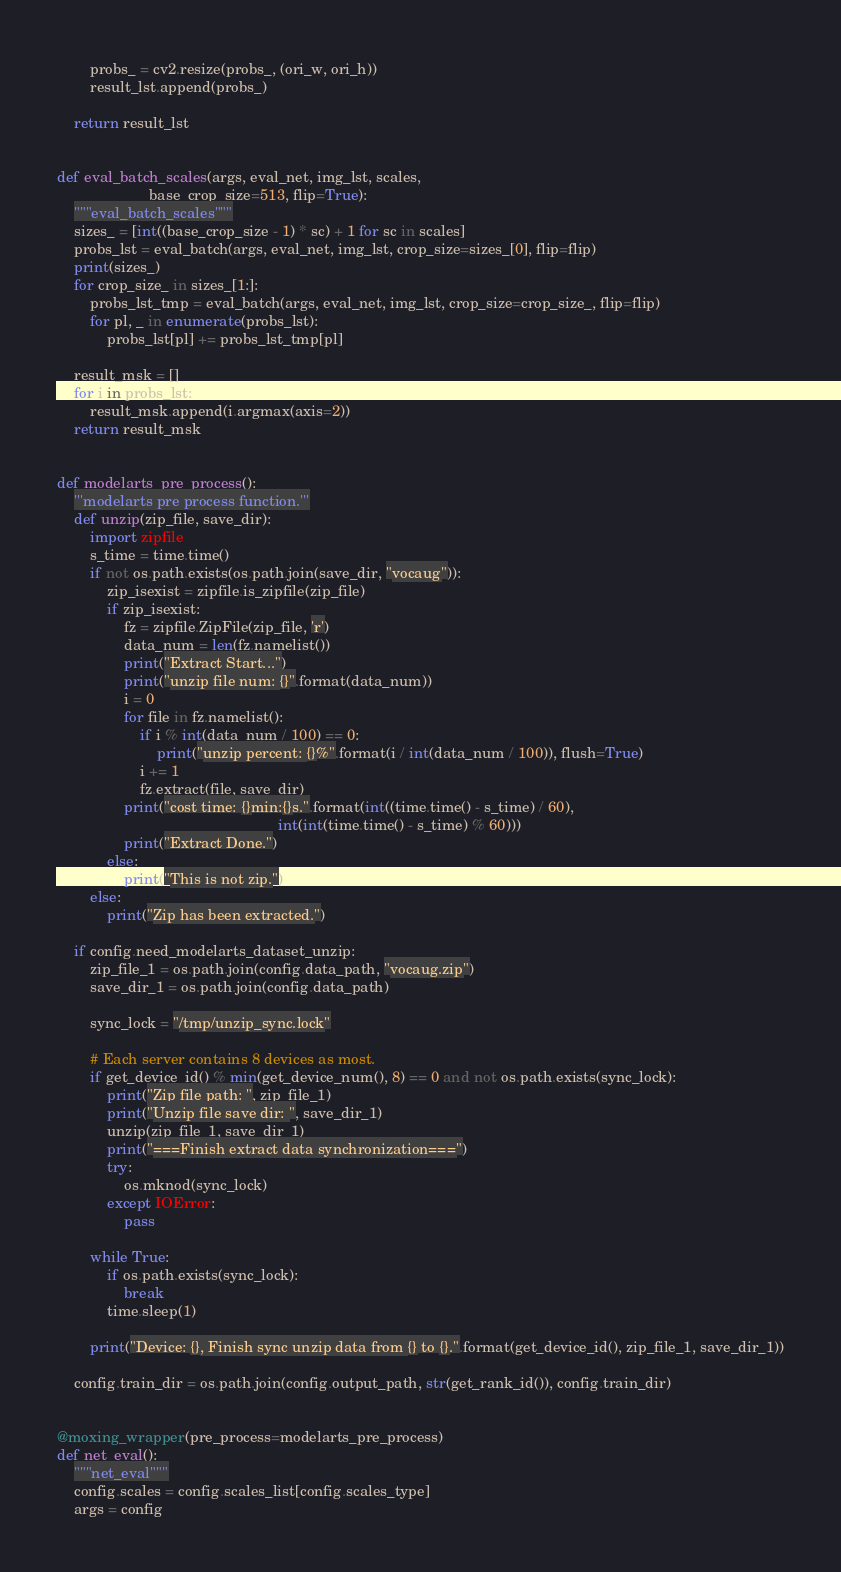Convert code to text. <code><loc_0><loc_0><loc_500><loc_500><_Python_>        probs_ = cv2.resize(probs_, (ori_w, ori_h))
        result_lst.append(probs_)

    return result_lst


def eval_batch_scales(args, eval_net, img_lst, scales,
                      base_crop_size=513, flip=True):
    """eval_batch_scales"""
    sizes_ = [int((base_crop_size - 1) * sc) + 1 for sc in scales]
    probs_lst = eval_batch(args, eval_net, img_lst, crop_size=sizes_[0], flip=flip)
    print(sizes_)
    for crop_size_ in sizes_[1:]:
        probs_lst_tmp = eval_batch(args, eval_net, img_lst, crop_size=crop_size_, flip=flip)
        for pl, _ in enumerate(probs_lst):
            probs_lst[pl] += probs_lst_tmp[pl]

    result_msk = []
    for i in probs_lst:
        result_msk.append(i.argmax(axis=2))
    return result_msk


def modelarts_pre_process():
    '''modelarts pre process function.'''
    def unzip(zip_file, save_dir):
        import zipfile
        s_time = time.time()
        if not os.path.exists(os.path.join(save_dir, "vocaug")):
            zip_isexist = zipfile.is_zipfile(zip_file)
            if zip_isexist:
                fz = zipfile.ZipFile(zip_file, 'r')
                data_num = len(fz.namelist())
                print("Extract Start...")
                print("unzip file num: {}".format(data_num))
                i = 0
                for file in fz.namelist():
                    if i % int(data_num / 100) == 0:
                        print("unzip percent: {}%".format(i / int(data_num / 100)), flush=True)
                    i += 1
                    fz.extract(file, save_dir)
                print("cost time: {}min:{}s.".format(int((time.time() - s_time) / 60),
                                                     int(int(time.time() - s_time) % 60)))
                print("Extract Done.")
            else:
                print("This is not zip.")
        else:
            print("Zip has been extracted.")

    if config.need_modelarts_dataset_unzip:
        zip_file_1 = os.path.join(config.data_path, "vocaug.zip")
        save_dir_1 = os.path.join(config.data_path)

        sync_lock = "/tmp/unzip_sync.lock"

        # Each server contains 8 devices as most.
        if get_device_id() % min(get_device_num(), 8) == 0 and not os.path.exists(sync_lock):
            print("Zip file path: ", zip_file_1)
            print("Unzip file save dir: ", save_dir_1)
            unzip(zip_file_1, save_dir_1)
            print("===Finish extract data synchronization===")
            try:
                os.mknod(sync_lock)
            except IOError:
                pass

        while True:
            if os.path.exists(sync_lock):
                break
            time.sleep(1)

        print("Device: {}, Finish sync unzip data from {} to {}.".format(get_device_id(), zip_file_1, save_dir_1))

    config.train_dir = os.path.join(config.output_path, str(get_rank_id()), config.train_dir)


@moxing_wrapper(pre_process=modelarts_pre_process)
def net_eval():
    """net_eval"""
    config.scales = config.scales_list[config.scales_type]
    args = config
</code> 